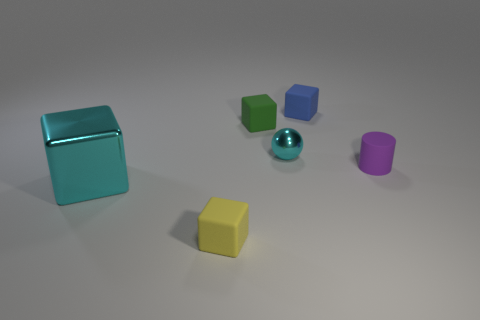Add 2 small green blocks. How many objects exist? 8 Subtract all balls. How many objects are left? 5 Subtract 0 red cylinders. How many objects are left? 6 Subtract all red things. Subtract all cyan metal blocks. How many objects are left? 5 Add 6 purple cylinders. How many purple cylinders are left? 7 Add 2 small blue blocks. How many small blue blocks exist? 3 